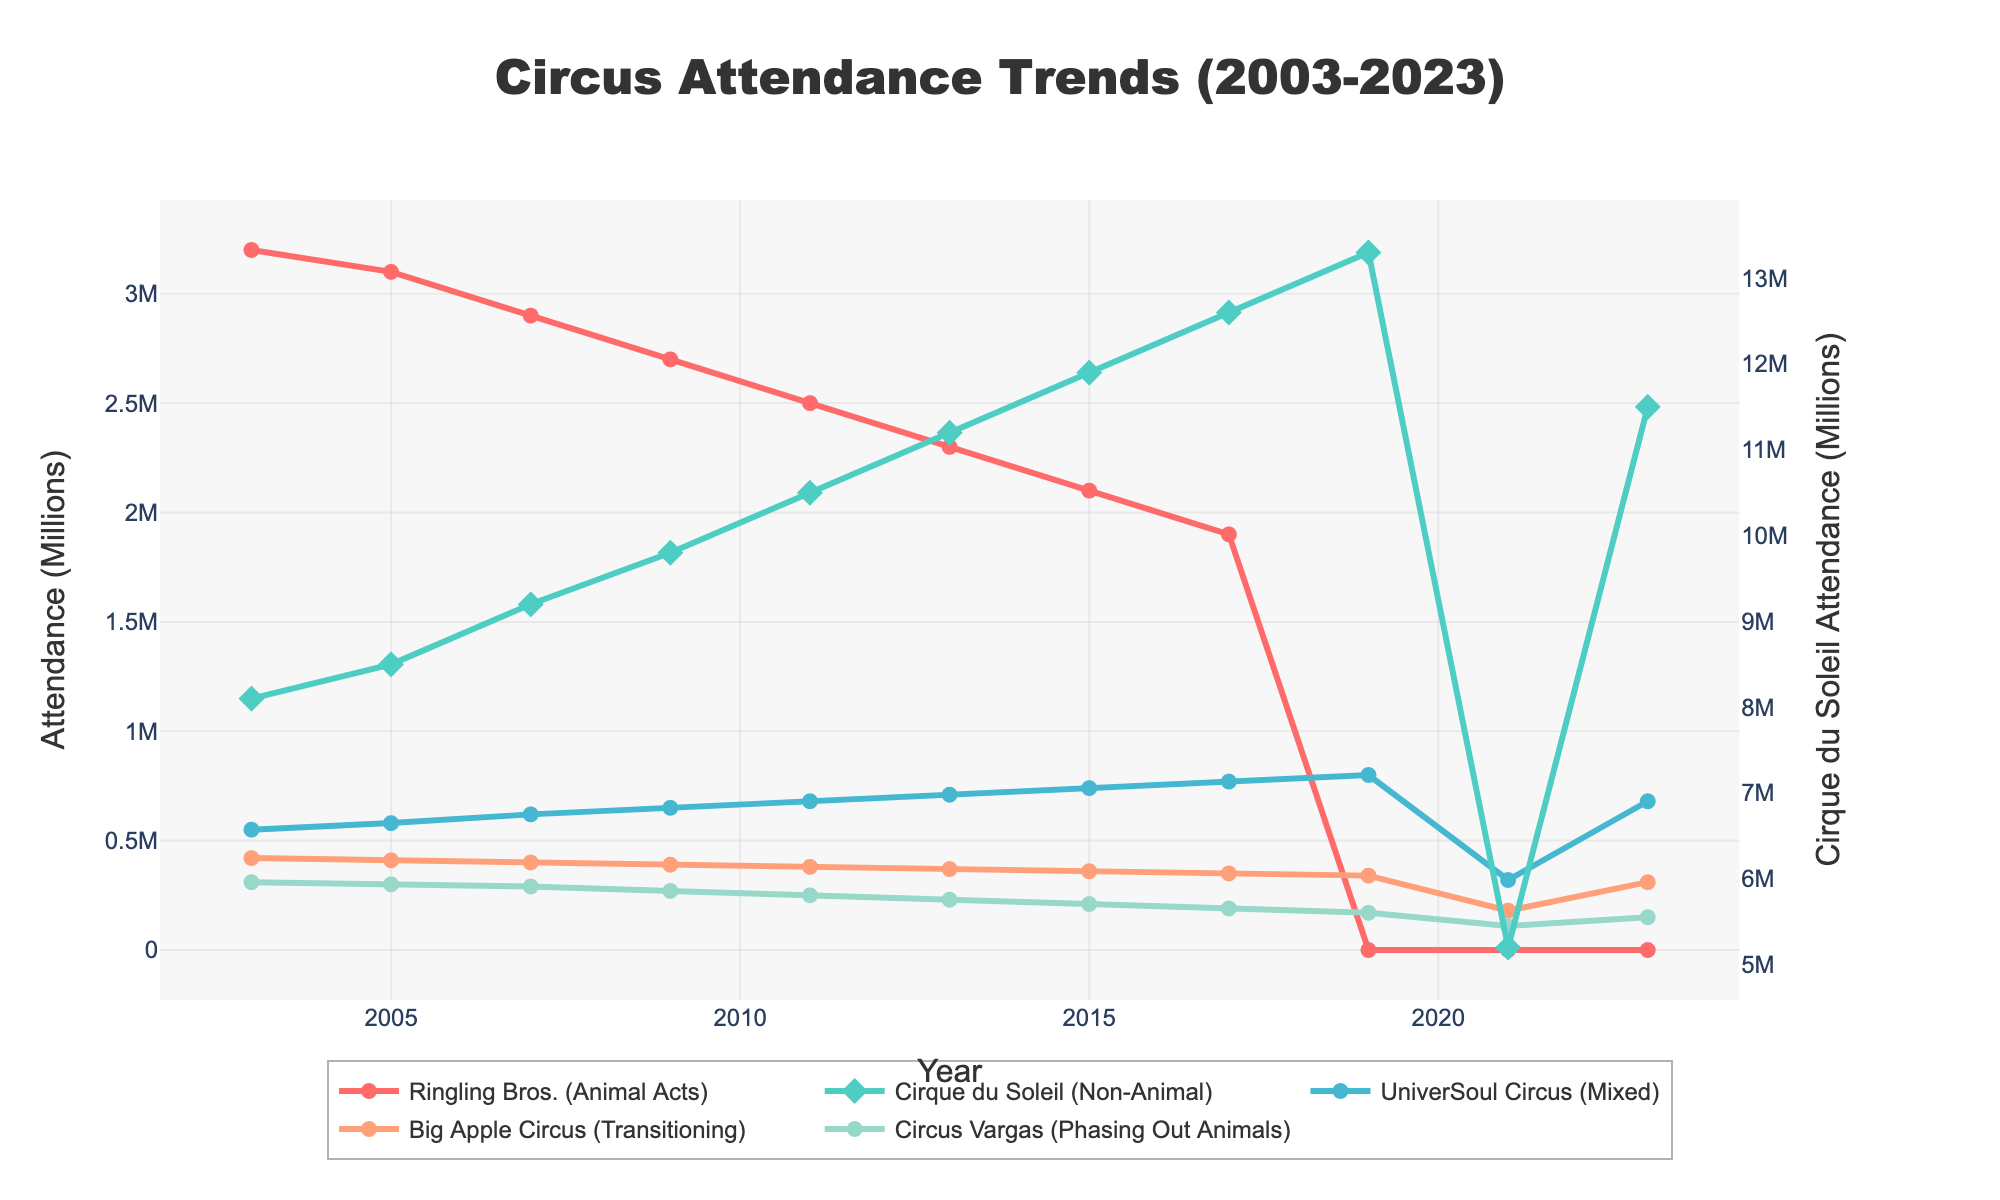What's the average attendance of Ringling Bros. (Animal Acts) from 2003 to 2017? Sum the attendance values for Ringling Bros. from 2003 to 2017 and then divide by the number of years. (3200000 + 3100000 + 2900000 + 2700000 + 2500000 + 2300000 + 2100000 + 1900000) / 8 = 25400000 / 8 = 3175000
Answer: 3175000 Which circus had the highest attendance in 2023? Look at the attendance values for all circuses in 2023 and identify the highest value. Cirque du Soleil has the highest attendance of 11500000
Answer: Cirque du Soleil How did the attendance of Cirque du Soleil change from 2019 to 2021? Compare the attendance values of Cirque du Soleil in 2019 and 2021. 13300000 (2019) - 5200000 (2021) = 8100000
Answer: Decreased by 8100000 What was the attendance trend for UniverSoul Circus (Mixed) from 2003 to 2023? Observe the attendance values for UniverSoul Circus (Mixed) over the years. The attendance shows a general increasing trend from 550000 in 2003 to 800000 in 2019 and then a smaller peak at 680000 in 2023
Answer: Increasing trend What is the total attendance of Big Apple Circus (Transitioning) in the years 2017, 2019, 2021, and 2023 combined? Sum the attendance values of Big Apple Circus for the years 2017, 2019, 2021, and 2023. 350000 + 340000 + 180000 + 310000 = 1180000
Answer: 1180000 Which circus attendance is represented by the visual element with the thickest line? Determine the circus represented by the thickest line in the figure. Cirque du Soleil (Non-Animal) is represented by the thickest line
Answer: Cirque du Soleil By what factor did the attendance of Circus Vargas (Phasing Out Animals) decrease from 2003 to 2023? Compare the attendance values in 2003 and 2023 and divide the earlier value by the later value. 310000 / 150000 = 2.0667
Answer: Decreased by a factor of roughly 2.1 Is there any year where Ringling Bros. and Cirque du Soleil have equal attendance? Check for any overlapping values in the attendance numbers of Ringling Bros. and Cirque du Soleil. There are no overlapping attendance values for these circuses.
Answer: No How many more people attended Big Apple Circus in 2003 compared to 2023? Subtract the attendance number of Big Apple Circus in 2023 from that in 2003. 420000 - 310000 = 110000
Answer: 110000 Which circus switched from having the most attendance to eliminating its animal acts entirely, and in what year did this change occur? Identify the circus with the highest attendance before and after the given change. Ringling Bros. had eliminated animal acts; this change occurred in 2019.
Answer: Ringling Bros., 2019 